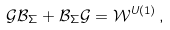<formula> <loc_0><loc_0><loc_500><loc_500>\mathcal { G B } _ { \Sigma } + \mathcal { B } _ { \Sigma } \mathcal { G = W } ^ { U ( 1 ) } \, ,</formula> 